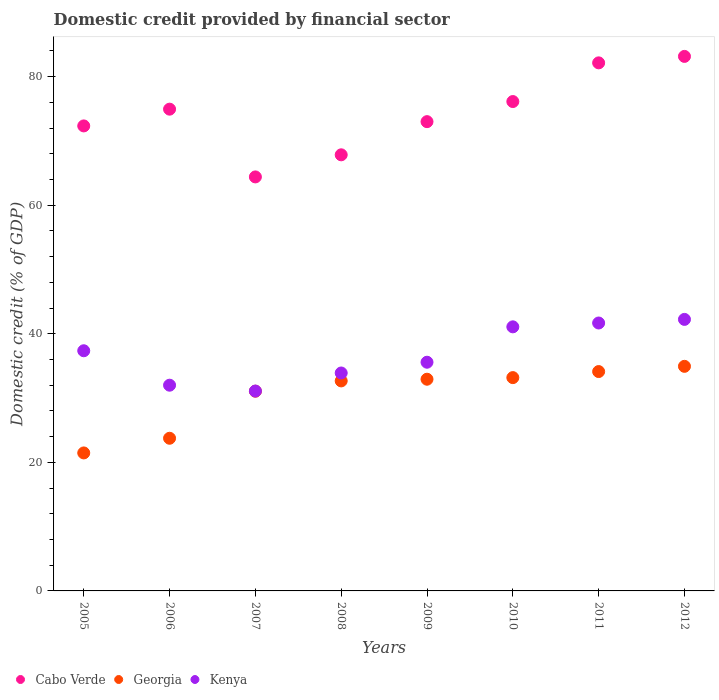How many different coloured dotlines are there?
Give a very brief answer. 3. Is the number of dotlines equal to the number of legend labels?
Your answer should be very brief. Yes. What is the domestic credit in Kenya in 2005?
Your response must be concise. 37.36. Across all years, what is the maximum domestic credit in Cabo Verde?
Make the answer very short. 83.15. Across all years, what is the minimum domestic credit in Georgia?
Your answer should be compact. 21.47. In which year was the domestic credit in Cabo Verde minimum?
Keep it short and to the point. 2007. What is the total domestic credit in Kenya in the graph?
Keep it short and to the point. 294.93. What is the difference between the domestic credit in Kenya in 2005 and that in 2011?
Make the answer very short. -4.32. What is the difference between the domestic credit in Cabo Verde in 2011 and the domestic credit in Kenya in 2007?
Keep it short and to the point. 51.05. What is the average domestic credit in Cabo Verde per year?
Your answer should be very brief. 74.24. In the year 2010, what is the difference between the domestic credit in Kenya and domestic credit in Georgia?
Provide a short and direct response. 7.9. What is the ratio of the domestic credit in Cabo Verde in 2006 to that in 2008?
Your answer should be very brief. 1.1. Is the domestic credit in Cabo Verde in 2005 less than that in 2012?
Your answer should be compact. Yes. What is the difference between the highest and the second highest domestic credit in Kenya?
Give a very brief answer. 0.56. What is the difference between the highest and the lowest domestic credit in Kenya?
Your response must be concise. 11.15. In how many years, is the domestic credit in Kenya greater than the average domestic credit in Kenya taken over all years?
Offer a very short reply. 4. Is it the case that in every year, the sum of the domestic credit in Georgia and domestic credit in Kenya  is greater than the domestic credit in Cabo Verde?
Make the answer very short. No. Is the domestic credit in Cabo Verde strictly greater than the domestic credit in Kenya over the years?
Provide a succinct answer. Yes. Is the domestic credit in Cabo Verde strictly less than the domestic credit in Georgia over the years?
Your answer should be very brief. No. How many dotlines are there?
Provide a short and direct response. 3. What is the difference between two consecutive major ticks on the Y-axis?
Your answer should be very brief. 20. Are the values on the major ticks of Y-axis written in scientific E-notation?
Provide a succinct answer. No. How are the legend labels stacked?
Make the answer very short. Horizontal. What is the title of the graph?
Ensure brevity in your answer.  Domestic credit provided by financial sector. Does "Kiribati" appear as one of the legend labels in the graph?
Offer a very short reply. No. What is the label or title of the X-axis?
Offer a terse response. Years. What is the label or title of the Y-axis?
Offer a terse response. Domestic credit (% of GDP). What is the Domestic credit (% of GDP) of Cabo Verde in 2005?
Ensure brevity in your answer.  72.34. What is the Domestic credit (% of GDP) of Georgia in 2005?
Provide a short and direct response. 21.47. What is the Domestic credit (% of GDP) of Kenya in 2005?
Give a very brief answer. 37.36. What is the Domestic credit (% of GDP) in Cabo Verde in 2006?
Keep it short and to the point. 74.94. What is the Domestic credit (% of GDP) in Georgia in 2006?
Make the answer very short. 23.75. What is the Domestic credit (% of GDP) in Kenya in 2006?
Make the answer very short. 32. What is the Domestic credit (% of GDP) of Cabo Verde in 2007?
Keep it short and to the point. 64.4. What is the Domestic credit (% of GDP) of Georgia in 2007?
Ensure brevity in your answer.  31.07. What is the Domestic credit (% of GDP) in Kenya in 2007?
Provide a succinct answer. 31.09. What is the Domestic credit (% of GDP) in Cabo Verde in 2008?
Your response must be concise. 67.84. What is the Domestic credit (% of GDP) of Georgia in 2008?
Your answer should be very brief. 32.67. What is the Domestic credit (% of GDP) in Kenya in 2008?
Offer a very short reply. 33.9. What is the Domestic credit (% of GDP) of Cabo Verde in 2009?
Give a very brief answer. 73. What is the Domestic credit (% of GDP) of Georgia in 2009?
Ensure brevity in your answer.  32.93. What is the Domestic credit (% of GDP) in Kenya in 2009?
Ensure brevity in your answer.  35.58. What is the Domestic credit (% of GDP) in Cabo Verde in 2010?
Keep it short and to the point. 76.13. What is the Domestic credit (% of GDP) in Georgia in 2010?
Your answer should be very brief. 33.18. What is the Domestic credit (% of GDP) in Kenya in 2010?
Provide a short and direct response. 41.08. What is the Domestic credit (% of GDP) of Cabo Verde in 2011?
Offer a terse response. 82.15. What is the Domestic credit (% of GDP) of Georgia in 2011?
Make the answer very short. 34.12. What is the Domestic credit (% of GDP) in Kenya in 2011?
Provide a short and direct response. 41.68. What is the Domestic credit (% of GDP) in Cabo Verde in 2012?
Your answer should be very brief. 83.15. What is the Domestic credit (% of GDP) in Georgia in 2012?
Make the answer very short. 34.94. What is the Domestic credit (% of GDP) in Kenya in 2012?
Offer a terse response. 42.24. Across all years, what is the maximum Domestic credit (% of GDP) in Cabo Verde?
Provide a succinct answer. 83.15. Across all years, what is the maximum Domestic credit (% of GDP) in Georgia?
Your response must be concise. 34.94. Across all years, what is the maximum Domestic credit (% of GDP) of Kenya?
Your answer should be very brief. 42.24. Across all years, what is the minimum Domestic credit (% of GDP) of Cabo Verde?
Ensure brevity in your answer.  64.4. Across all years, what is the minimum Domestic credit (% of GDP) in Georgia?
Your response must be concise. 21.47. Across all years, what is the minimum Domestic credit (% of GDP) of Kenya?
Ensure brevity in your answer.  31.09. What is the total Domestic credit (% of GDP) of Cabo Verde in the graph?
Provide a short and direct response. 593.95. What is the total Domestic credit (% of GDP) in Georgia in the graph?
Offer a very short reply. 244.13. What is the total Domestic credit (% of GDP) of Kenya in the graph?
Your response must be concise. 294.93. What is the difference between the Domestic credit (% of GDP) of Cabo Verde in 2005 and that in 2006?
Offer a very short reply. -2.61. What is the difference between the Domestic credit (% of GDP) of Georgia in 2005 and that in 2006?
Your response must be concise. -2.28. What is the difference between the Domestic credit (% of GDP) in Kenya in 2005 and that in 2006?
Your answer should be very brief. 5.36. What is the difference between the Domestic credit (% of GDP) in Cabo Verde in 2005 and that in 2007?
Provide a short and direct response. 7.93. What is the difference between the Domestic credit (% of GDP) in Georgia in 2005 and that in 2007?
Your answer should be compact. -9.6. What is the difference between the Domestic credit (% of GDP) in Kenya in 2005 and that in 2007?
Ensure brevity in your answer.  6.27. What is the difference between the Domestic credit (% of GDP) of Cabo Verde in 2005 and that in 2008?
Offer a terse response. 4.5. What is the difference between the Domestic credit (% of GDP) in Georgia in 2005 and that in 2008?
Your answer should be very brief. -11.2. What is the difference between the Domestic credit (% of GDP) of Kenya in 2005 and that in 2008?
Provide a succinct answer. 3.46. What is the difference between the Domestic credit (% of GDP) of Cabo Verde in 2005 and that in 2009?
Your answer should be very brief. -0.66. What is the difference between the Domestic credit (% of GDP) of Georgia in 2005 and that in 2009?
Make the answer very short. -11.47. What is the difference between the Domestic credit (% of GDP) in Kenya in 2005 and that in 2009?
Offer a very short reply. 1.78. What is the difference between the Domestic credit (% of GDP) in Cabo Verde in 2005 and that in 2010?
Your answer should be very brief. -3.79. What is the difference between the Domestic credit (% of GDP) of Georgia in 2005 and that in 2010?
Make the answer very short. -11.72. What is the difference between the Domestic credit (% of GDP) in Kenya in 2005 and that in 2010?
Ensure brevity in your answer.  -3.72. What is the difference between the Domestic credit (% of GDP) of Cabo Verde in 2005 and that in 2011?
Your answer should be compact. -9.81. What is the difference between the Domestic credit (% of GDP) in Georgia in 2005 and that in 2011?
Make the answer very short. -12.66. What is the difference between the Domestic credit (% of GDP) in Kenya in 2005 and that in 2011?
Your response must be concise. -4.32. What is the difference between the Domestic credit (% of GDP) of Cabo Verde in 2005 and that in 2012?
Your answer should be very brief. -10.81. What is the difference between the Domestic credit (% of GDP) of Georgia in 2005 and that in 2012?
Offer a terse response. -13.47. What is the difference between the Domestic credit (% of GDP) of Kenya in 2005 and that in 2012?
Your answer should be compact. -4.88. What is the difference between the Domestic credit (% of GDP) of Cabo Verde in 2006 and that in 2007?
Ensure brevity in your answer.  10.54. What is the difference between the Domestic credit (% of GDP) in Georgia in 2006 and that in 2007?
Your answer should be very brief. -7.32. What is the difference between the Domestic credit (% of GDP) of Kenya in 2006 and that in 2007?
Provide a short and direct response. 0.91. What is the difference between the Domestic credit (% of GDP) of Cabo Verde in 2006 and that in 2008?
Provide a succinct answer. 7.1. What is the difference between the Domestic credit (% of GDP) of Georgia in 2006 and that in 2008?
Make the answer very short. -8.92. What is the difference between the Domestic credit (% of GDP) in Kenya in 2006 and that in 2008?
Provide a succinct answer. -1.9. What is the difference between the Domestic credit (% of GDP) of Cabo Verde in 2006 and that in 2009?
Your response must be concise. 1.94. What is the difference between the Domestic credit (% of GDP) in Georgia in 2006 and that in 2009?
Make the answer very short. -9.18. What is the difference between the Domestic credit (% of GDP) in Kenya in 2006 and that in 2009?
Ensure brevity in your answer.  -3.57. What is the difference between the Domestic credit (% of GDP) of Cabo Verde in 2006 and that in 2010?
Provide a succinct answer. -1.18. What is the difference between the Domestic credit (% of GDP) in Georgia in 2006 and that in 2010?
Your answer should be very brief. -9.43. What is the difference between the Domestic credit (% of GDP) of Kenya in 2006 and that in 2010?
Keep it short and to the point. -9.08. What is the difference between the Domestic credit (% of GDP) in Cabo Verde in 2006 and that in 2011?
Provide a short and direct response. -7.2. What is the difference between the Domestic credit (% of GDP) of Georgia in 2006 and that in 2011?
Your answer should be compact. -10.38. What is the difference between the Domestic credit (% of GDP) in Kenya in 2006 and that in 2011?
Your answer should be very brief. -9.68. What is the difference between the Domestic credit (% of GDP) of Cabo Verde in 2006 and that in 2012?
Your answer should be compact. -8.21. What is the difference between the Domestic credit (% of GDP) in Georgia in 2006 and that in 2012?
Keep it short and to the point. -11.19. What is the difference between the Domestic credit (% of GDP) in Kenya in 2006 and that in 2012?
Give a very brief answer. -10.24. What is the difference between the Domestic credit (% of GDP) of Cabo Verde in 2007 and that in 2008?
Your response must be concise. -3.44. What is the difference between the Domestic credit (% of GDP) of Georgia in 2007 and that in 2008?
Your answer should be compact. -1.6. What is the difference between the Domestic credit (% of GDP) in Kenya in 2007 and that in 2008?
Your answer should be very brief. -2.81. What is the difference between the Domestic credit (% of GDP) in Cabo Verde in 2007 and that in 2009?
Your answer should be compact. -8.6. What is the difference between the Domestic credit (% of GDP) of Georgia in 2007 and that in 2009?
Make the answer very short. -1.87. What is the difference between the Domestic credit (% of GDP) of Kenya in 2007 and that in 2009?
Give a very brief answer. -4.48. What is the difference between the Domestic credit (% of GDP) of Cabo Verde in 2007 and that in 2010?
Provide a short and direct response. -11.72. What is the difference between the Domestic credit (% of GDP) in Georgia in 2007 and that in 2010?
Your response must be concise. -2.12. What is the difference between the Domestic credit (% of GDP) in Kenya in 2007 and that in 2010?
Give a very brief answer. -9.99. What is the difference between the Domestic credit (% of GDP) of Cabo Verde in 2007 and that in 2011?
Your answer should be compact. -17.74. What is the difference between the Domestic credit (% of GDP) in Georgia in 2007 and that in 2011?
Keep it short and to the point. -3.06. What is the difference between the Domestic credit (% of GDP) in Kenya in 2007 and that in 2011?
Offer a very short reply. -10.59. What is the difference between the Domestic credit (% of GDP) in Cabo Verde in 2007 and that in 2012?
Your answer should be compact. -18.75. What is the difference between the Domestic credit (% of GDP) in Georgia in 2007 and that in 2012?
Your response must be concise. -3.87. What is the difference between the Domestic credit (% of GDP) in Kenya in 2007 and that in 2012?
Provide a short and direct response. -11.15. What is the difference between the Domestic credit (% of GDP) in Cabo Verde in 2008 and that in 2009?
Your answer should be compact. -5.16. What is the difference between the Domestic credit (% of GDP) of Georgia in 2008 and that in 2009?
Provide a succinct answer. -0.26. What is the difference between the Domestic credit (% of GDP) of Kenya in 2008 and that in 2009?
Give a very brief answer. -1.67. What is the difference between the Domestic credit (% of GDP) in Cabo Verde in 2008 and that in 2010?
Your answer should be compact. -8.29. What is the difference between the Domestic credit (% of GDP) in Georgia in 2008 and that in 2010?
Offer a terse response. -0.51. What is the difference between the Domestic credit (% of GDP) of Kenya in 2008 and that in 2010?
Provide a short and direct response. -7.18. What is the difference between the Domestic credit (% of GDP) in Cabo Verde in 2008 and that in 2011?
Give a very brief answer. -14.31. What is the difference between the Domestic credit (% of GDP) of Georgia in 2008 and that in 2011?
Offer a very short reply. -1.45. What is the difference between the Domestic credit (% of GDP) of Kenya in 2008 and that in 2011?
Provide a short and direct response. -7.78. What is the difference between the Domestic credit (% of GDP) in Cabo Verde in 2008 and that in 2012?
Give a very brief answer. -15.31. What is the difference between the Domestic credit (% of GDP) of Georgia in 2008 and that in 2012?
Offer a terse response. -2.27. What is the difference between the Domestic credit (% of GDP) in Kenya in 2008 and that in 2012?
Provide a short and direct response. -8.34. What is the difference between the Domestic credit (% of GDP) of Cabo Verde in 2009 and that in 2010?
Your answer should be compact. -3.13. What is the difference between the Domestic credit (% of GDP) of Georgia in 2009 and that in 2010?
Ensure brevity in your answer.  -0.25. What is the difference between the Domestic credit (% of GDP) of Kenya in 2009 and that in 2010?
Make the answer very short. -5.5. What is the difference between the Domestic credit (% of GDP) of Cabo Verde in 2009 and that in 2011?
Make the answer very short. -9.15. What is the difference between the Domestic credit (% of GDP) in Georgia in 2009 and that in 2011?
Your response must be concise. -1.19. What is the difference between the Domestic credit (% of GDP) of Kenya in 2009 and that in 2011?
Provide a succinct answer. -6.1. What is the difference between the Domestic credit (% of GDP) of Cabo Verde in 2009 and that in 2012?
Provide a short and direct response. -10.15. What is the difference between the Domestic credit (% of GDP) of Georgia in 2009 and that in 2012?
Offer a terse response. -2. What is the difference between the Domestic credit (% of GDP) in Kenya in 2009 and that in 2012?
Your response must be concise. -6.66. What is the difference between the Domestic credit (% of GDP) of Cabo Verde in 2010 and that in 2011?
Your response must be concise. -6.02. What is the difference between the Domestic credit (% of GDP) of Georgia in 2010 and that in 2011?
Your answer should be very brief. -0.94. What is the difference between the Domestic credit (% of GDP) of Kenya in 2010 and that in 2011?
Your answer should be very brief. -0.6. What is the difference between the Domestic credit (% of GDP) of Cabo Verde in 2010 and that in 2012?
Keep it short and to the point. -7.02. What is the difference between the Domestic credit (% of GDP) of Georgia in 2010 and that in 2012?
Keep it short and to the point. -1.75. What is the difference between the Domestic credit (% of GDP) in Kenya in 2010 and that in 2012?
Ensure brevity in your answer.  -1.16. What is the difference between the Domestic credit (% of GDP) in Cabo Verde in 2011 and that in 2012?
Provide a succinct answer. -1. What is the difference between the Domestic credit (% of GDP) in Georgia in 2011 and that in 2012?
Provide a succinct answer. -0.81. What is the difference between the Domestic credit (% of GDP) of Kenya in 2011 and that in 2012?
Your answer should be very brief. -0.56. What is the difference between the Domestic credit (% of GDP) of Cabo Verde in 2005 and the Domestic credit (% of GDP) of Georgia in 2006?
Offer a terse response. 48.59. What is the difference between the Domestic credit (% of GDP) in Cabo Verde in 2005 and the Domestic credit (% of GDP) in Kenya in 2006?
Offer a terse response. 40.33. What is the difference between the Domestic credit (% of GDP) in Georgia in 2005 and the Domestic credit (% of GDP) in Kenya in 2006?
Keep it short and to the point. -10.54. What is the difference between the Domestic credit (% of GDP) in Cabo Verde in 2005 and the Domestic credit (% of GDP) in Georgia in 2007?
Provide a succinct answer. 41.27. What is the difference between the Domestic credit (% of GDP) of Cabo Verde in 2005 and the Domestic credit (% of GDP) of Kenya in 2007?
Your response must be concise. 41.24. What is the difference between the Domestic credit (% of GDP) in Georgia in 2005 and the Domestic credit (% of GDP) in Kenya in 2007?
Your answer should be very brief. -9.63. What is the difference between the Domestic credit (% of GDP) in Cabo Verde in 2005 and the Domestic credit (% of GDP) in Georgia in 2008?
Keep it short and to the point. 39.67. What is the difference between the Domestic credit (% of GDP) of Cabo Verde in 2005 and the Domestic credit (% of GDP) of Kenya in 2008?
Ensure brevity in your answer.  38.43. What is the difference between the Domestic credit (% of GDP) of Georgia in 2005 and the Domestic credit (% of GDP) of Kenya in 2008?
Provide a succinct answer. -12.44. What is the difference between the Domestic credit (% of GDP) of Cabo Verde in 2005 and the Domestic credit (% of GDP) of Georgia in 2009?
Provide a succinct answer. 39.4. What is the difference between the Domestic credit (% of GDP) in Cabo Verde in 2005 and the Domestic credit (% of GDP) in Kenya in 2009?
Your answer should be compact. 36.76. What is the difference between the Domestic credit (% of GDP) of Georgia in 2005 and the Domestic credit (% of GDP) of Kenya in 2009?
Your answer should be compact. -14.11. What is the difference between the Domestic credit (% of GDP) in Cabo Verde in 2005 and the Domestic credit (% of GDP) in Georgia in 2010?
Make the answer very short. 39.16. What is the difference between the Domestic credit (% of GDP) of Cabo Verde in 2005 and the Domestic credit (% of GDP) of Kenya in 2010?
Offer a terse response. 31.26. What is the difference between the Domestic credit (% of GDP) in Georgia in 2005 and the Domestic credit (% of GDP) in Kenya in 2010?
Your response must be concise. -19.62. What is the difference between the Domestic credit (% of GDP) of Cabo Verde in 2005 and the Domestic credit (% of GDP) of Georgia in 2011?
Provide a short and direct response. 38.21. What is the difference between the Domestic credit (% of GDP) in Cabo Verde in 2005 and the Domestic credit (% of GDP) in Kenya in 2011?
Keep it short and to the point. 30.66. What is the difference between the Domestic credit (% of GDP) of Georgia in 2005 and the Domestic credit (% of GDP) of Kenya in 2011?
Offer a terse response. -20.21. What is the difference between the Domestic credit (% of GDP) in Cabo Verde in 2005 and the Domestic credit (% of GDP) in Georgia in 2012?
Offer a very short reply. 37.4. What is the difference between the Domestic credit (% of GDP) in Cabo Verde in 2005 and the Domestic credit (% of GDP) in Kenya in 2012?
Give a very brief answer. 30.1. What is the difference between the Domestic credit (% of GDP) of Georgia in 2005 and the Domestic credit (% of GDP) of Kenya in 2012?
Make the answer very short. -20.77. What is the difference between the Domestic credit (% of GDP) in Cabo Verde in 2006 and the Domestic credit (% of GDP) in Georgia in 2007?
Offer a very short reply. 43.88. What is the difference between the Domestic credit (% of GDP) in Cabo Verde in 2006 and the Domestic credit (% of GDP) in Kenya in 2007?
Provide a succinct answer. 43.85. What is the difference between the Domestic credit (% of GDP) of Georgia in 2006 and the Domestic credit (% of GDP) of Kenya in 2007?
Provide a short and direct response. -7.34. What is the difference between the Domestic credit (% of GDP) of Cabo Verde in 2006 and the Domestic credit (% of GDP) of Georgia in 2008?
Your answer should be very brief. 42.27. What is the difference between the Domestic credit (% of GDP) in Cabo Verde in 2006 and the Domestic credit (% of GDP) in Kenya in 2008?
Offer a terse response. 41.04. What is the difference between the Domestic credit (% of GDP) in Georgia in 2006 and the Domestic credit (% of GDP) in Kenya in 2008?
Give a very brief answer. -10.15. What is the difference between the Domestic credit (% of GDP) in Cabo Verde in 2006 and the Domestic credit (% of GDP) in Georgia in 2009?
Ensure brevity in your answer.  42.01. What is the difference between the Domestic credit (% of GDP) of Cabo Verde in 2006 and the Domestic credit (% of GDP) of Kenya in 2009?
Ensure brevity in your answer.  39.37. What is the difference between the Domestic credit (% of GDP) of Georgia in 2006 and the Domestic credit (% of GDP) of Kenya in 2009?
Offer a terse response. -11.83. What is the difference between the Domestic credit (% of GDP) in Cabo Verde in 2006 and the Domestic credit (% of GDP) in Georgia in 2010?
Provide a succinct answer. 41.76. What is the difference between the Domestic credit (% of GDP) in Cabo Verde in 2006 and the Domestic credit (% of GDP) in Kenya in 2010?
Offer a very short reply. 33.86. What is the difference between the Domestic credit (% of GDP) of Georgia in 2006 and the Domestic credit (% of GDP) of Kenya in 2010?
Keep it short and to the point. -17.33. What is the difference between the Domestic credit (% of GDP) in Cabo Verde in 2006 and the Domestic credit (% of GDP) in Georgia in 2011?
Provide a succinct answer. 40.82. What is the difference between the Domestic credit (% of GDP) of Cabo Verde in 2006 and the Domestic credit (% of GDP) of Kenya in 2011?
Provide a succinct answer. 33.27. What is the difference between the Domestic credit (% of GDP) in Georgia in 2006 and the Domestic credit (% of GDP) in Kenya in 2011?
Keep it short and to the point. -17.93. What is the difference between the Domestic credit (% of GDP) of Cabo Verde in 2006 and the Domestic credit (% of GDP) of Georgia in 2012?
Keep it short and to the point. 40.01. What is the difference between the Domestic credit (% of GDP) in Cabo Verde in 2006 and the Domestic credit (% of GDP) in Kenya in 2012?
Provide a succinct answer. 32.7. What is the difference between the Domestic credit (% of GDP) of Georgia in 2006 and the Domestic credit (% of GDP) of Kenya in 2012?
Offer a terse response. -18.49. What is the difference between the Domestic credit (% of GDP) of Cabo Verde in 2007 and the Domestic credit (% of GDP) of Georgia in 2008?
Give a very brief answer. 31.73. What is the difference between the Domestic credit (% of GDP) in Cabo Verde in 2007 and the Domestic credit (% of GDP) in Kenya in 2008?
Make the answer very short. 30.5. What is the difference between the Domestic credit (% of GDP) in Georgia in 2007 and the Domestic credit (% of GDP) in Kenya in 2008?
Ensure brevity in your answer.  -2.84. What is the difference between the Domestic credit (% of GDP) in Cabo Verde in 2007 and the Domestic credit (% of GDP) in Georgia in 2009?
Make the answer very short. 31.47. What is the difference between the Domestic credit (% of GDP) of Cabo Verde in 2007 and the Domestic credit (% of GDP) of Kenya in 2009?
Your answer should be compact. 28.83. What is the difference between the Domestic credit (% of GDP) in Georgia in 2007 and the Domestic credit (% of GDP) in Kenya in 2009?
Ensure brevity in your answer.  -4.51. What is the difference between the Domestic credit (% of GDP) in Cabo Verde in 2007 and the Domestic credit (% of GDP) in Georgia in 2010?
Provide a short and direct response. 31.22. What is the difference between the Domestic credit (% of GDP) of Cabo Verde in 2007 and the Domestic credit (% of GDP) of Kenya in 2010?
Offer a terse response. 23.32. What is the difference between the Domestic credit (% of GDP) in Georgia in 2007 and the Domestic credit (% of GDP) in Kenya in 2010?
Your answer should be compact. -10.01. What is the difference between the Domestic credit (% of GDP) of Cabo Verde in 2007 and the Domestic credit (% of GDP) of Georgia in 2011?
Ensure brevity in your answer.  30.28. What is the difference between the Domestic credit (% of GDP) of Cabo Verde in 2007 and the Domestic credit (% of GDP) of Kenya in 2011?
Your answer should be compact. 22.73. What is the difference between the Domestic credit (% of GDP) in Georgia in 2007 and the Domestic credit (% of GDP) in Kenya in 2011?
Offer a very short reply. -10.61. What is the difference between the Domestic credit (% of GDP) of Cabo Verde in 2007 and the Domestic credit (% of GDP) of Georgia in 2012?
Your response must be concise. 29.47. What is the difference between the Domestic credit (% of GDP) of Cabo Verde in 2007 and the Domestic credit (% of GDP) of Kenya in 2012?
Your answer should be compact. 22.16. What is the difference between the Domestic credit (% of GDP) in Georgia in 2007 and the Domestic credit (% of GDP) in Kenya in 2012?
Offer a terse response. -11.17. What is the difference between the Domestic credit (% of GDP) of Cabo Verde in 2008 and the Domestic credit (% of GDP) of Georgia in 2009?
Your response must be concise. 34.91. What is the difference between the Domestic credit (% of GDP) of Cabo Verde in 2008 and the Domestic credit (% of GDP) of Kenya in 2009?
Your response must be concise. 32.26. What is the difference between the Domestic credit (% of GDP) of Georgia in 2008 and the Domestic credit (% of GDP) of Kenya in 2009?
Keep it short and to the point. -2.91. What is the difference between the Domestic credit (% of GDP) in Cabo Verde in 2008 and the Domestic credit (% of GDP) in Georgia in 2010?
Offer a terse response. 34.66. What is the difference between the Domestic credit (% of GDP) of Cabo Verde in 2008 and the Domestic credit (% of GDP) of Kenya in 2010?
Ensure brevity in your answer.  26.76. What is the difference between the Domestic credit (% of GDP) of Georgia in 2008 and the Domestic credit (% of GDP) of Kenya in 2010?
Your response must be concise. -8.41. What is the difference between the Domestic credit (% of GDP) in Cabo Verde in 2008 and the Domestic credit (% of GDP) in Georgia in 2011?
Offer a terse response. 33.72. What is the difference between the Domestic credit (% of GDP) in Cabo Verde in 2008 and the Domestic credit (% of GDP) in Kenya in 2011?
Provide a succinct answer. 26.16. What is the difference between the Domestic credit (% of GDP) of Georgia in 2008 and the Domestic credit (% of GDP) of Kenya in 2011?
Provide a succinct answer. -9.01. What is the difference between the Domestic credit (% of GDP) in Cabo Verde in 2008 and the Domestic credit (% of GDP) in Georgia in 2012?
Your answer should be compact. 32.9. What is the difference between the Domestic credit (% of GDP) of Cabo Verde in 2008 and the Domestic credit (% of GDP) of Kenya in 2012?
Your answer should be very brief. 25.6. What is the difference between the Domestic credit (% of GDP) in Georgia in 2008 and the Domestic credit (% of GDP) in Kenya in 2012?
Your response must be concise. -9.57. What is the difference between the Domestic credit (% of GDP) of Cabo Verde in 2009 and the Domestic credit (% of GDP) of Georgia in 2010?
Your answer should be compact. 39.82. What is the difference between the Domestic credit (% of GDP) in Cabo Verde in 2009 and the Domestic credit (% of GDP) in Kenya in 2010?
Your answer should be very brief. 31.92. What is the difference between the Domestic credit (% of GDP) of Georgia in 2009 and the Domestic credit (% of GDP) of Kenya in 2010?
Your response must be concise. -8.15. What is the difference between the Domestic credit (% of GDP) of Cabo Verde in 2009 and the Domestic credit (% of GDP) of Georgia in 2011?
Your response must be concise. 38.88. What is the difference between the Domestic credit (% of GDP) of Cabo Verde in 2009 and the Domestic credit (% of GDP) of Kenya in 2011?
Ensure brevity in your answer.  31.32. What is the difference between the Domestic credit (% of GDP) of Georgia in 2009 and the Domestic credit (% of GDP) of Kenya in 2011?
Offer a terse response. -8.75. What is the difference between the Domestic credit (% of GDP) in Cabo Verde in 2009 and the Domestic credit (% of GDP) in Georgia in 2012?
Ensure brevity in your answer.  38.06. What is the difference between the Domestic credit (% of GDP) in Cabo Verde in 2009 and the Domestic credit (% of GDP) in Kenya in 2012?
Your answer should be compact. 30.76. What is the difference between the Domestic credit (% of GDP) of Georgia in 2009 and the Domestic credit (% of GDP) of Kenya in 2012?
Your answer should be compact. -9.31. What is the difference between the Domestic credit (% of GDP) of Cabo Verde in 2010 and the Domestic credit (% of GDP) of Georgia in 2011?
Give a very brief answer. 42. What is the difference between the Domestic credit (% of GDP) of Cabo Verde in 2010 and the Domestic credit (% of GDP) of Kenya in 2011?
Offer a very short reply. 34.45. What is the difference between the Domestic credit (% of GDP) in Georgia in 2010 and the Domestic credit (% of GDP) in Kenya in 2011?
Your answer should be compact. -8.5. What is the difference between the Domestic credit (% of GDP) of Cabo Verde in 2010 and the Domestic credit (% of GDP) of Georgia in 2012?
Ensure brevity in your answer.  41.19. What is the difference between the Domestic credit (% of GDP) of Cabo Verde in 2010 and the Domestic credit (% of GDP) of Kenya in 2012?
Your response must be concise. 33.89. What is the difference between the Domestic credit (% of GDP) in Georgia in 2010 and the Domestic credit (% of GDP) in Kenya in 2012?
Keep it short and to the point. -9.06. What is the difference between the Domestic credit (% of GDP) in Cabo Verde in 2011 and the Domestic credit (% of GDP) in Georgia in 2012?
Provide a short and direct response. 47.21. What is the difference between the Domestic credit (% of GDP) of Cabo Verde in 2011 and the Domestic credit (% of GDP) of Kenya in 2012?
Give a very brief answer. 39.91. What is the difference between the Domestic credit (% of GDP) in Georgia in 2011 and the Domestic credit (% of GDP) in Kenya in 2012?
Offer a very short reply. -8.12. What is the average Domestic credit (% of GDP) of Cabo Verde per year?
Your answer should be very brief. 74.24. What is the average Domestic credit (% of GDP) of Georgia per year?
Make the answer very short. 30.52. What is the average Domestic credit (% of GDP) of Kenya per year?
Your response must be concise. 36.87. In the year 2005, what is the difference between the Domestic credit (% of GDP) in Cabo Verde and Domestic credit (% of GDP) in Georgia?
Provide a succinct answer. 50.87. In the year 2005, what is the difference between the Domestic credit (% of GDP) in Cabo Verde and Domestic credit (% of GDP) in Kenya?
Provide a short and direct response. 34.98. In the year 2005, what is the difference between the Domestic credit (% of GDP) in Georgia and Domestic credit (% of GDP) in Kenya?
Provide a succinct answer. -15.9. In the year 2006, what is the difference between the Domestic credit (% of GDP) in Cabo Verde and Domestic credit (% of GDP) in Georgia?
Offer a terse response. 51.19. In the year 2006, what is the difference between the Domestic credit (% of GDP) in Cabo Verde and Domestic credit (% of GDP) in Kenya?
Keep it short and to the point. 42.94. In the year 2006, what is the difference between the Domestic credit (% of GDP) in Georgia and Domestic credit (% of GDP) in Kenya?
Your answer should be very brief. -8.25. In the year 2007, what is the difference between the Domestic credit (% of GDP) in Cabo Verde and Domestic credit (% of GDP) in Georgia?
Your response must be concise. 33.34. In the year 2007, what is the difference between the Domestic credit (% of GDP) of Cabo Verde and Domestic credit (% of GDP) of Kenya?
Your response must be concise. 33.31. In the year 2007, what is the difference between the Domestic credit (% of GDP) in Georgia and Domestic credit (% of GDP) in Kenya?
Make the answer very short. -0.03. In the year 2008, what is the difference between the Domestic credit (% of GDP) in Cabo Verde and Domestic credit (% of GDP) in Georgia?
Give a very brief answer. 35.17. In the year 2008, what is the difference between the Domestic credit (% of GDP) of Cabo Verde and Domestic credit (% of GDP) of Kenya?
Give a very brief answer. 33.94. In the year 2008, what is the difference between the Domestic credit (% of GDP) in Georgia and Domestic credit (% of GDP) in Kenya?
Offer a very short reply. -1.23. In the year 2009, what is the difference between the Domestic credit (% of GDP) of Cabo Verde and Domestic credit (% of GDP) of Georgia?
Offer a very short reply. 40.07. In the year 2009, what is the difference between the Domestic credit (% of GDP) in Cabo Verde and Domestic credit (% of GDP) in Kenya?
Provide a succinct answer. 37.42. In the year 2009, what is the difference between the Domestic credit (% of GDP) in Georgia and Domestic credit (% of GDP) in Kenya?
Your answer should be very brief. -2.64. In the year 2010, what is the difference between the Domestic credit (% of GDP) of Cabo Verde and Domestic credit (% of GDP) of Georgia?
Provide a succinct answer. 42.95. In the year 2010, what is the difference between the Domestic credit (% of GDP) of Cabo Verde and Domestic credit (% of GDP) of Kenya?
Offer a very short reply. 35.05. In the year 2010, what is the difference between the Domestic credit (% of GDP) in Georgia and Domestic credit (% of GDP) in Kenya?
Provide a short and direct response. -7.9. In the year 2011, what is the difference between the Domestic credit (% of GDP) of Cabo Verde and Domestic credit (% of GDP) of Georgia?
Ensure brevity in your answer.  48.02. In the year 2011, what is the difference between the Domestic credit (% of GDP) of Cabo Verde and Domestic credit (% of GDP) of Kenya?
Ensure brevity in your answer.  40.47. In the year 2011, what is the difference between the Domestic credit (% of GDP) of Georgia and Domestic credit (% of GDP) of Kenya?
Your answer should be compact. -7.55. In the year 2012, what is the difference between the Domestic credit (% of GDP) in Cabo Verde and Domestic credit (% of GDP) in Georgia?
Make the answer very short. 48.21. In the year 2012, what is the difference between the Domestic credit (% of GDP) in Cabo Verde and Domestic credit (% of GDP) in Kenya?
Your answer should be compact. 40.91. In the year 2012, what is the difference between the Domestic credit (% of GDP) in Georgia and Domestic credit (% of GDP) in Kenya?
Your response must be concise. -7.3. What is the ratio of the Domestic credit (% of GDP) of Cabo Verde in 2005 to that in 2006?
Your answer should be very brief. 0.97. What is the ratio of the Domestic credit (% of GDP) in Georgia in 2005 to that in 2006?
Give a very brief answer. 0.9. What is the ratio of the Domestic credit (% of GDP) of Kenya in 2005 to that in 2006?
Ensure brevity in your answer.  1.17. What is the ratio of the Domestic credit (% of GDP) of Cabo Verde in 2005 to that in 2007?
Your answer should be very brief. 1.12. What is the ratio of the Domestic credit (% of GDP) in Georgia in 2005 to that in 2007?
Provide a succinct answer. 0.69. What is the ratio of the Domestic credit (% of GDP) in Kenya in 2005 to that in 2007?
Offer a very short reply. 1.2. What is the ratio of the Domestic credit (% of GDP) in Cabo Verde in 2005 to that in 2008?
Ensure brevity in your answer.  1.07. What is the ratio of the Domestic credit (% of GDP) in Georgia in 2005 to that in 2008?
Offer a very short reply. 0.66. What is the ratio of the Domestic credit (% of GDP) of Kenya in 2005 to that in 2008?
Your response must be concise. 1.1. What is the ratio of the Domestic credit (% of GDP) of Cabo Verde in 2005 to that in 2009?
Your answer should be compact. 0.99. What is the ratio of the Domestic credit (% of GDP) of Georgia in 2005 to that in 2009?
Offer a terse response. 0.65. What is the ratio of the Domestic credit (% of GDP) in Kenya in 2005 to that in 2009?
Your answer should be compact. 1.05. What is the ratio of the Domestic credit (% of GDP) in Cabo Verde in 2005 to that in 2010?
Keep it short and to the point. 0.95. What is the ratio of the Domestic credit (% of GDP) of Georgia in 2005 to that in 2010?
Provide a short and direct response. 0.65. What is the ratio of the Domestic credit (% of GDP) of Kenya in 2005 to that in 2010?
Your answer should be compact. 0.91. What is the ratio of the Domestic credit (% of GDP) in Cabo Verde in 2005 to that in 2011?
Provide a short and direct response. 0.88. What is the ratio of the Domestic credit (% of GDP) of Georgia in 2005 to that in 2011?
Provide a succinct answer. 0.63. What is the ratio of the Domestic credit (% of GDP) of Kenya in 2005 to that in 2011?
Your response must be concise. 0.9. What is the ratio of the Domestic credit (% of GDP) in Cabo Verde in 2005 to that in 2012?
Keep it short and to the point. 0.87. What is the ratio of the Domestic credit (% of GDP) in Georgia in 2005 to that in 2012?
Give a very brief answer. 0.61. What is the ratio of the Domestic credit (% of GDP) in Kenya in 2005 to that in 2012?
Make the answer very short. 0.88. What is the ratio of the Domestic credit (% of GDP) of Cabo Verde in 2006 to that in 2007?
Give a very brief answer. 1.16. What is the ratio of the Domestic credit (% of GDP) of Georgia in 2006 to that in 2007?
Keep it short and to the point. 0.76. What is the ratio of the Domestic credit (% of GDP) of Kenya in 2006 to that in 2007?
Your answer should be compact. 1.03. What is the ratio of the Domestic credit (% of GDP) of Cabo Verde in 2006 to that in 2008?
Your answer should be very brief. 1.1. What is the ratio of the Domestic credit (% of GDP) in Georgia in 2006 to that in 2008?
Provide a succinct answer. 0.73. What is the ratio of the Domestic credit (% of GDP) of Kenya in 2006 to that in 2008?
Ensure brevity in your answer.  0.94. What is the ratio of the Domestic credit (% of GDP) of Cabo Verde in 2006 to that in 2009?
Give a very brief answer. 1.03. What is the ratio of the Domestic credit (% of GDP) of Georgia in 2006 to that in 2009?
Keep it short and to the point. 0.72. What is the ratio of the Domestic credit (% of GDP) of Kenya in 2006 to that in 2009?
Offer a terse response. 0.9. What is the ratio of the Domestic credit (% of GDP) in Cabo Verde in 2006 to that in 2010?
Provide a succinct answer. 0.98. What is the ratio of the Domestic credit (% of GDP) of Georgia in 2006 to that in 2010?
Your answer should be very brief. 0.72. What is the ratio of the Domestic credit (% of GDP) of Kenya in 2006 to that in 2010?
Ensure brevity in your answer.  0.78. What is the ratio of the Domestic credit (% of GDP) in Cabo Verde in 2006 to that in 2011?
Provide a short and direct response. 0.91. What is the ratio of the Domestic credit (% of GDP) in Georgia in 2006 to that in 2011?
Ensure brevity in your answer.  0.7. What is the ratio of the Domestic credit (% of GDP) of Kenya in 2006 to that in 2011?
Offer a very short reply. 0.77. What is the ratio of the Domestic credit (% of GDP) in Cabo Verde in 2006 to that in 2012?
Ensure brevity in your answer.  0.9. What is the ratio of the Domestic credit (% of GDP) of Georgia in 2006 to that in 2012?
Provide a short and direct response. 0.68. What is the ratio of the Domestic credit (% of GDP) in Kenya in 2006 to that in 2012?
Offer a terse response. 0.76. What is the ratio of the Domestic credit (% of GDP) of Cabo Verde in 2007 to that in 2008?
Your answer should be compact. 0.95. What is the ratio of the Domestic credit (% of GDP) of Georgia in 2007 to that in 2008?
Provide a succinct answer. 0.95. What is the ratio of the Domestic credit (% of GDP) in Kenya in 2007 to that in 2008?
Your response must be concise. 0.92. What is the ratio of the Domestic credit (% of GDP) of Cabo Verde in 2007 to that in 2009?
Make the answer very short. 0.88. What is the ratio of the Domestic credit (% of GDP) of Georgia in 2007 to that in 2009?
Your response must be concise. 0.94. What is the ratio of the Domestic credit (% of GDP) in Kenya in 2007 to that in 2009?
Give a very brief answer. 0.87. What is the ratio of the Domestic credit (% of GDP) in Cabo Verde in 2007 to that in 2010?
Give a very brief answer. 0.85. What is the ratio of the Domestic credit (% of GDP) in Georgia in 2007 to that in 2010?
Your answer should be compact. 0.94. What is the ratio of the Domestic credit (% of GDP) of Kenya in 2007 to that in 2010?
Give a very brief answer. 0.76. What is the ratio of the Domestic credit (% of GDP) in Cabo Verde in 2007 to that in 2011?
Give a very brief answer. 0.78. What is the ratio of the Domestic credit (% of GDP) of Georgia in 2007 to that in 2011?
Make the answer very short. 0.91. What is the ratio of the Domestic credit (% of GDP) in Kenya in 2007 to that in 2011?
Your answer should be compact. 0.75. What is the ratio of the Domestic credit (% of GDP) of Cabo Verde in 2007 to that in 2012?
Offer a very short reply. 0.77. What is the ratio of the Domestic credit (% of GDP) in Georgia in 2007 to that in 2012?
Your response must be concise. 0.89. What is the ratio of the Domestic credit (% of GDP) of Kenya in 2007 to that in 2012?
Give a very brief answer. 0.74. What is the ratio of the Domestic credit (% of GDP) in Cabo Verde in 2008 to that in 2009?
Your response must be concise. 0.93. What is the ratio of the Domestic credit (% of GDP) of Georgia in 2008 to that in 2009?
Ensure brevity in your answer.  0.99. What is the ratio of the Domestic credit (% of GDP) of Kenya in 2008 to that in 2009?
Offer a terse response. 0.95. What is the ratio of the Domestic credit (% of GDP) of Cabo Verde in 2008 to that in 2010?
Ensure brevity in your answer.  0.89. What is the ratio of the Domestic credit (% of GDP) of Georgia in 2008 to that in 2010?
Give a very brief answer. 0.98. What is the ratio of the Domestic credit (% of GDP) in Kenya in 2008 to that in 2010?
Your answer should be very brief. 0.83. What is the ratio of the Domestic credit (% of GDP) in Cabo Verde in 2008 to that in 2011?
Offer a terse response. 0.83. What is the ratio of the Domestic credit (% of GDP) in Georgia in 2008 to that in 2011?
Offer a very short reply. 0.96. What is the ratio of the Domestic credit (% of GDP) of Kenya in 2008 to that in 2011?
Make the answer very short. 0.81. What is the ratio of the Domestic credit (% of GDP) of Cabo Verde in 2008 to that in 2012?
Provide a succinct answer. 0.82. What is the ratio of the Domestic credit (% of GDP) in Georgia in 2008 to that in 2012?
Make the answer very short. 0.94. What is the ratio of the Domestic credit (% of GDP) of Kenya in 2008 to that in 2012?
Provide a short and direct response. 0.8. What is the ratio of the Domestic credit (% of GDP) in Cabo Verde in 2009 to that in 2010?
Offer a very short reply. 0.96. What is the ratio of the Domestic credit (% of GDP) in Georgia in 2009 to that in 2010?
Your answer should be compact. 0.99. What is the ratio of the Domestic credit (% of GDP) in Kenya in 2009 to that in 2010?
Your answer should be compact. 0.87. What is the ratio of the Domestic credit (% of GDP) of Cabo Verde in 2009 to that in 2011?
Provide a succinct answer. 0.89. What is the ratio of the Domestic credit (% of GDP) of Georgia in 2009 to that in 2011?
Your answer should be compact. 0.97. What is the ratio of the Domestic credit (% of GDP) in Kenya in 2009 to that in 2011?
Make the answer very short. 0.85. What is the ratio of the Domestic credit (% of GDP) in Cabo Verde in 2009 to that in 2012?
Offer a very short reply. 0.88. What is the ratio of the Domestic credit (% of GDP) in Georgia in 2009 to that in 2012?
Your answer should be compact. 0.94. What is the ratio of the Domestic credit (% of GDP) in Kenya in 2009 to that in 2012?
Keep it short and to the point. 0.84. What is the ratio of the Domestic credit (% of GDP) of Cabo Verde in 2010 to that in 2011?
Provide a short and direct response. 0.93. What is the ratio of the Domestic credit (% of GDP) of Georgia in 2010 to that in 2011?
Offer a very short reply. 0.97. What is the ratio of the Domestic credit (% of GDP) of Kenya in 2010 to that in 2011?
Offer a very short reply. 0.99. What is the ratio of the Domestic credit (% of GDP) of Cabo Verde in 2010 to that in 2012?
Offer a terse response. 0.92. What is the ratio of the Domestic credit (% of GDP) of Georgia in 2010 to that in 2012?
Your response must be concise. 0.95. What is the ratio of the Domestic credit (% of GDP) of Kenya in 2010 to that in 2012?
Offer a very short reply. 0.97. What is the ratio of the Domestic credit (% of GDP) in Cabo Verde in 2011 to that in 2012?
Make the answer very short. 0.99. What is the ratio of the Domestic credit (% of GDP) in Georgia in 2011 to that in 2012?
Provide a short and direct response. 0.98. What is the ratio of the Domestic credit (% of GDP) in Kenya in 2011 to that in 2012?
Ensure brevity in your answer.  0.99. What is the difference between the highest and the second highest Domestic credit (% of GDP) of Georgia?
Offer a very short reply. 0.81. What is the difference between the highest and the second highest Domestic credit (% of GDP) of Kenya?
Offer a very short reply. 0.56. What is the difference between the highest and the lowest Domestic credit (% of GDP) in Cabo Verde?
Your answer should be very brief. 18.75. What is the difference between the highest and the lowest Domestic credit (% of GDP) in Georgia?
Give a very brief answer. 13.47. What is the difference between the highest and the lowest Domestic credit (% of GDP) in Kenya?
Your response must be concise. 11.15. 